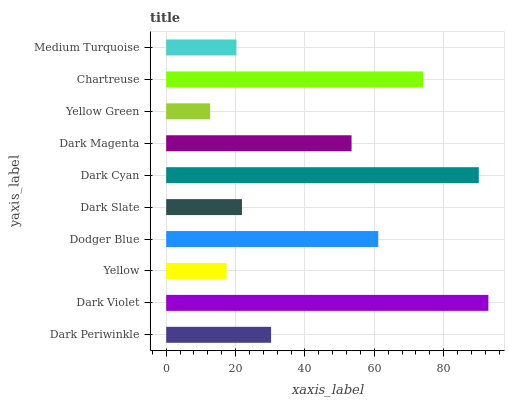Is Yellow Green the minimum?
Answer yes or no. Yes. Is Dark Violet the maximum?
Answer yes or no. Yes. Is Yellow the minimum?
Answer yes or no. No. Is Yellow the maximum?
Answer yes or no. No. Is Dark Violet greater than Yellow?
Answer yes or no. Yes. Is Yellow less than Dark Violet?
Answer yes or no. Yes. Is Yellow greater than Dark Violet?
Answer yes or no. No. Is Dark Violet less than Yellow?
Answer yes or no. No. Is Dark Magenta the high median?
Answer yes or no. Yes. Is Dark Periwinkle the low median?
Answer yes or no. Yes. Is Dark Slate the high median?
Answer yes or no. No. Is Yellow the low median?
Answer yes or no. No. 